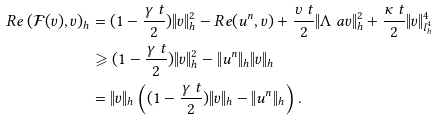Convert formula to latex. <formula><loc_0><loc_0><loc_500><loc_500>R e \left ( \mathcal { F } ( v ) , v \right ) _ { h } & = ( 1 - \frac { \gamma \ t } { 2 } ) \| v \| ^ { 2 } _ { h } - R e ( u ^ { n } , v ) + \frac { \upsilon \ t } { 2 } \| \Lambda ^ { \ } a v \| ^ { 2 } _ { h } + \frac { \kappa \ t } { 2 } \| v \| ^ { 4 } _ { l ^ { 4 } _ { h } } \\ & \geqslant ( 1 - \frac { \gamma \ t } { 2 } ) \| v \| ^ { 2 } _ { h } - \| u ^ { n } \| _ { h } \| v \| _ { h } \\ & = \| v \| _ { h } \left ( ( 1 - \frac { \gamma \ t } { 2 } ) \| v \| _ { h } - \| u ^ { n } \| _ { h } \right ) .</formula> 